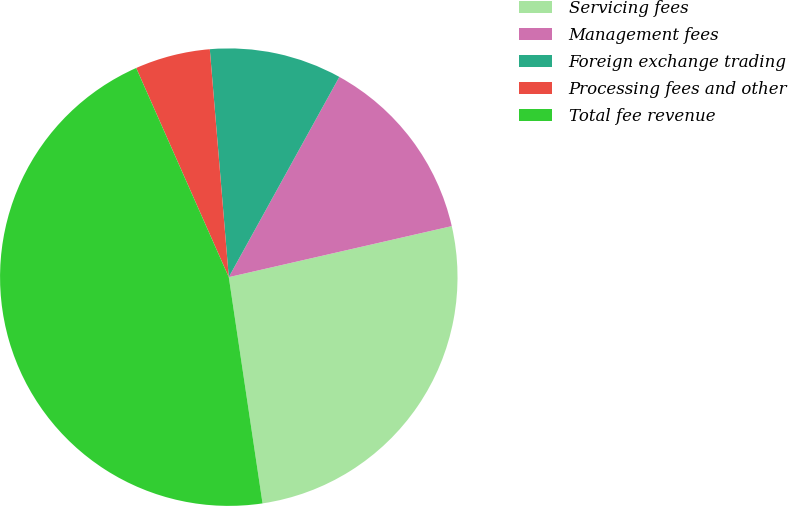<chart> <loc_0><loc_0><loc_500><loc_500><pie_chart><fcel>Servicing fees<fcel>Management fees<fcel>Foreign exchange trading<fcel>Processing fees and other<fcel>Total fee revenue<nl><fcel>26.22%<fcel>13.39%<fcel>9.35%<fcel>5.31%<fcel>45.72%<nl></chart> 